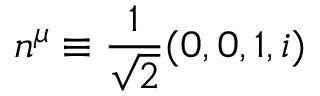<formula> <loc_0><loc_0><loc_500><loc_500>n ^ { \mu } \equiv \frac { 1 } { \sqrt { 2 } } ( 0 , 0 , 1 , i )</formula> 